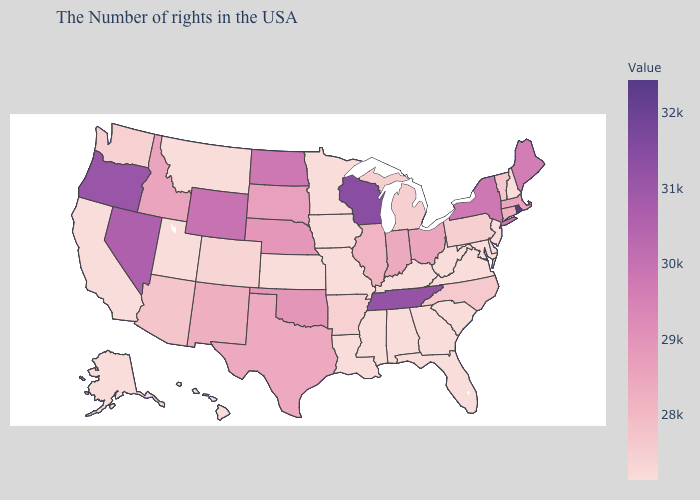Does Rhode Island have the highest value in the USA?
Answer briefly. Yes. Which states have the lowest value in the MidWest?
Keep it brief. Missouri, Minnesota, Iowa, Kansas. Which states have the lowest value in the USA?
Quick response, please. New Hampshire, New Jersey, Delaware, Maryland, Virginia, South Carolina, West Virginia, Florida, Georgia, Kentucky, Alabama, Mississippi, Louisiana, Missouri, Minnesota, Iowa, Kansas, Utah, Montana, California, Alaska, Hawaii. Among the states that border Wisconsin , which have the lowest value?
Write a very short answer. Minnesota, Iowa. Is the legend a continuous bar?
Be succinct. Yes. Does California have the highest value in the West?
Short answer required. No. 